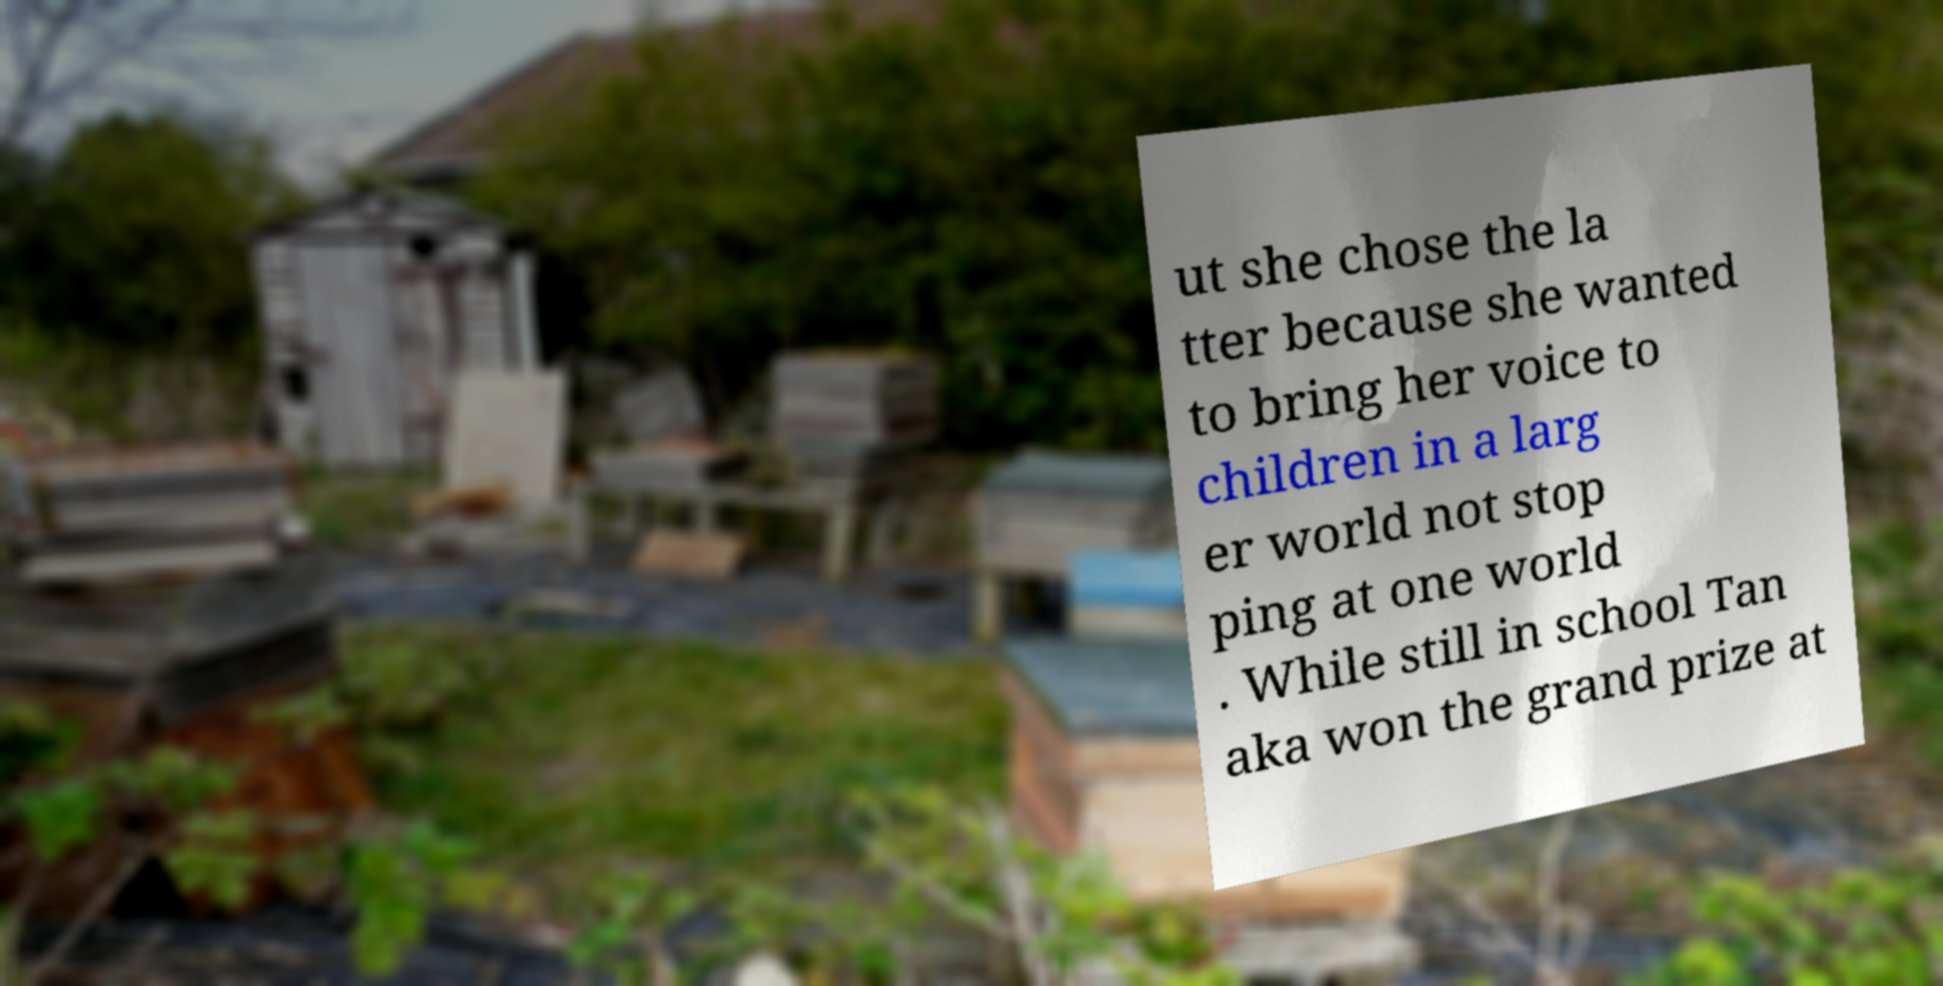Please read and relay the text visible in this image. What does it say? ut she chose the la tter because she wanted to bring her voice to children in a larg er world not stop ping at one world . While still in school Tan aka won the grand prize at 